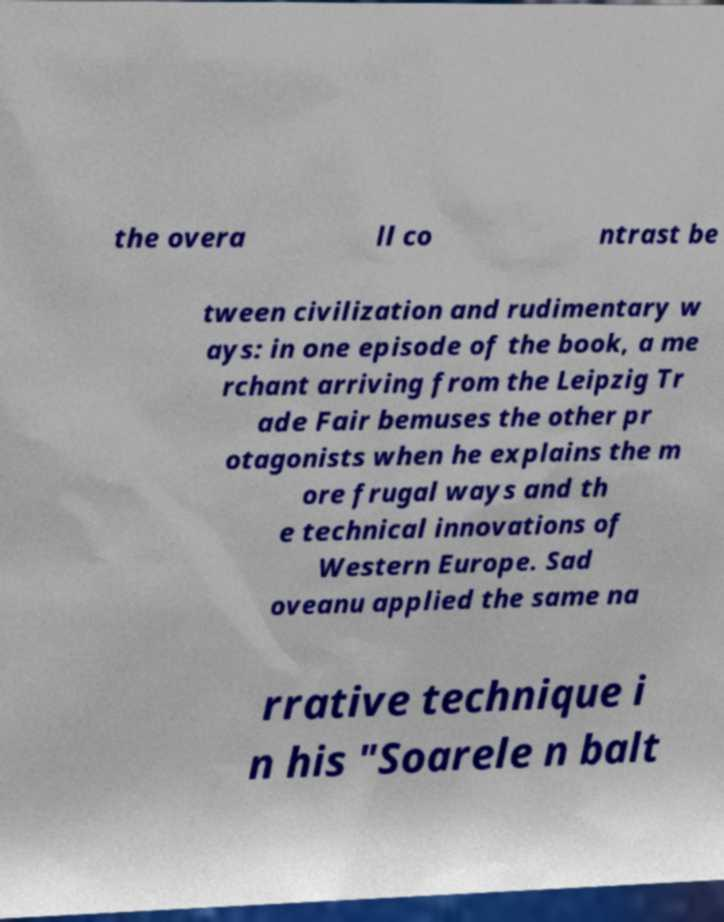There's text embedded in this image that I need extracted. Can you transcribe it verbatim? the overa ll co ntrast be tween civilization and rudimentary w ays: in one episode of the book, a me rchant arriving from the Leipzig Tr ade Fair bemuses the other pr otagonists when he explains the m ore frugal ways and th e technical innovations of Western Europe. Sad oveanu applied the same na rrative technique i n his "Soarele n balt 